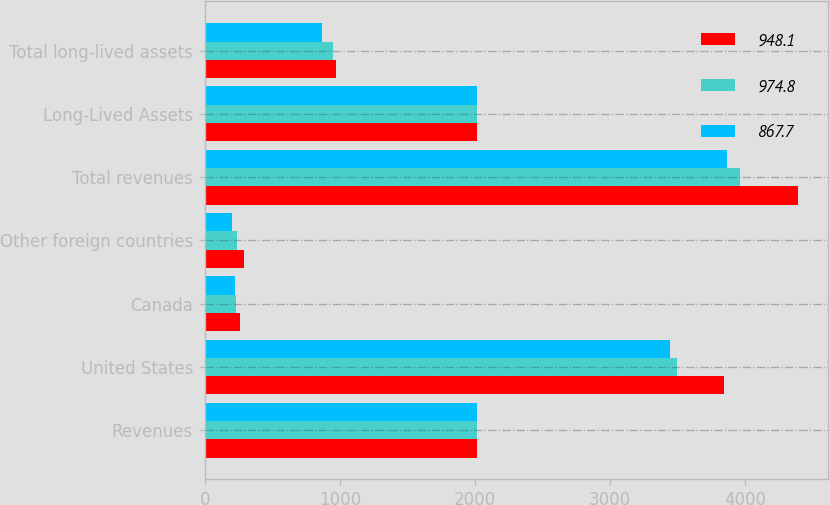<chart> <loc_0><loc_0><loc_500><loc_500><stacked_bar_chart><ecel><fcel>Revenues<fcel>United States<fcel>Canada<fcel>Other foreign countries<fcel>Total revenues<fcel>Long-Lived Assets<fcel>Total long-lived assets<nl><fcel>948.1<fcel>2017<fcel>3842.9<fcel>257.6<fcel>290<fcel>4390.5<fcel>2017<fcel>974.8<nl><fcel>974.8<fcel>2016<fcel>3493.5<fcel>228.7<fcel>239.8<fcel>3962<fcel>2016<fcel>948.1<nl><fcel>867.7<fcel>2015<fcel>3441.1<fcel>223.3<fcel>204.8<fcel>3869.2<fcel>2015<fcel>867.7<nl></chart> 